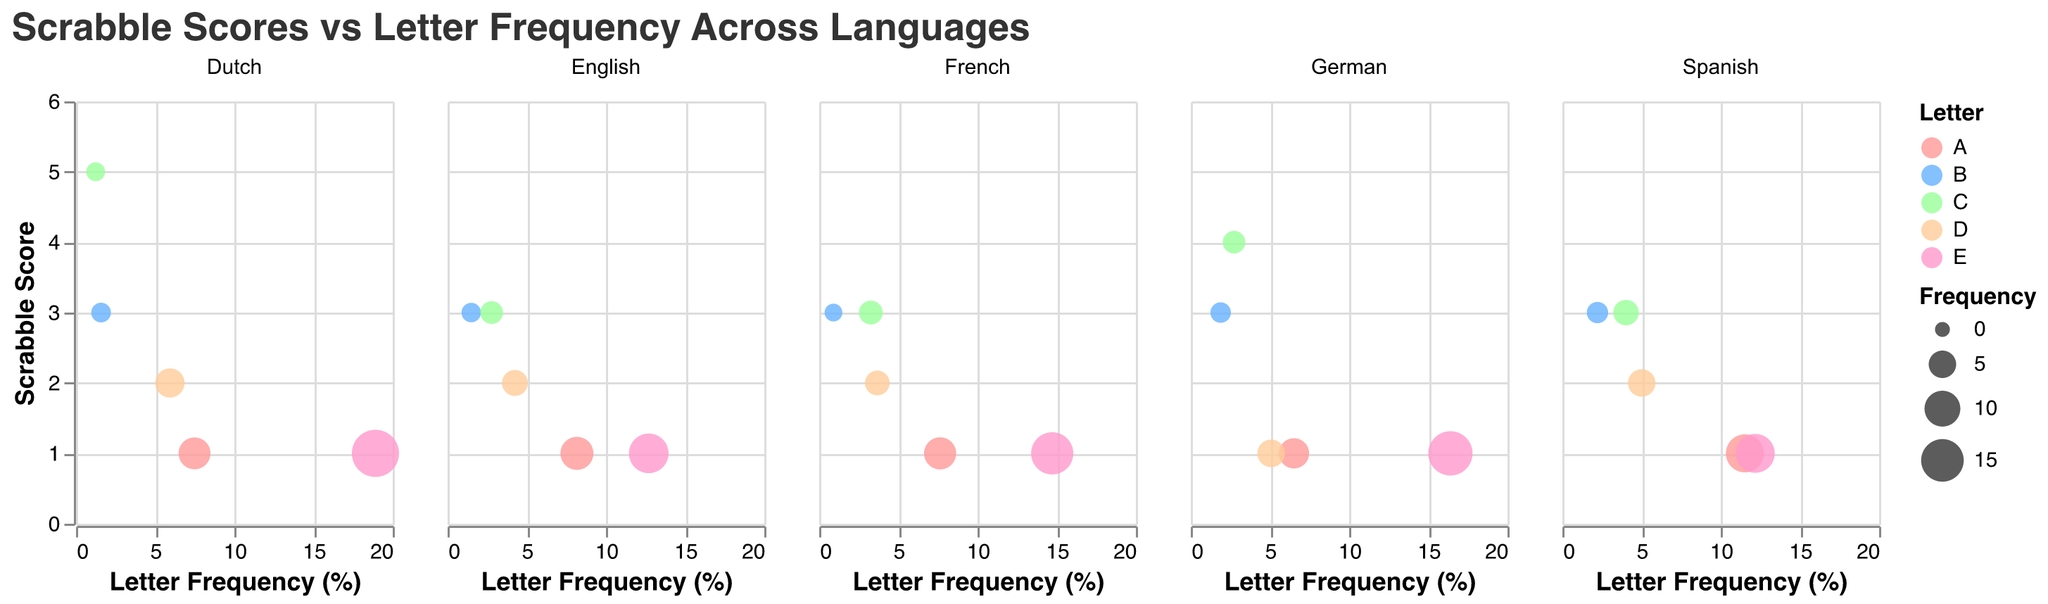What is the title of the figure? The title is displayed at the top of the figure in a larger, bold font for clarity. It reads "Scrabble Scores vs Letter Frequency Across Languages".
Answer: Scrabble Scores vs Letter Frequency Across Languages What is the range of the Letter Frequency axis? The X-axis represents Letter Frequency (%) and is set from 0 to 20, which is indicated by the axis scale in the plot.
Answer: 0 to 20 Which letter has the highest frequency in the Dutch language? In the sub-plot for Dutch, the bubble for the letter E is the largest, indicating that it has the highest frequency. The tooltip confirms this with a frequency of 18.91%.
Answer: E How many data points are plotted for the English language? The English language subplot has bubbles representing the letters A, B, C, D, and E. Counting these gives us 5 data points.
Answer: 5 Which letter in Spanish has a frequency above 10%? For Spanish, the bubbles representing letter frequencies show that both A and E have frequencies above 10%. The exact frequencies are displayed in the tooltip when hovered over these bubbles.
Answer: A and E What is the average Scrabble score for the letter C across all languages presented? Adding the Scrabble scores for C from English (3), Spanish (3), German (4), French (3), and Dutch (5), we get a total of 18. There are 5 languages, so the average score is 18/5 = 3.6.
Answer: 3.6 Which language has the highest frequency for the letter E? Observing the size of the bubbles and verifying with the tooltip, the subplot for Dutch shows that E has the highest frequency of 18.91%.
Answer: Dutch Compare the Scrabble score for the letter D in English and French. Which language has a higher score? Referring to the bubble positions on the Y-axis under English and French, English has a score of 2, and French has a score of 2 as well, so they are equal.
Answer: Equal What is the size range for the bubbles in the chart? The bubble size varies from a minimum size, corresponding to a frequency value being mapped to "50", to a maximum size value mapped to "500". This variation in bubble size reflects frequencies proportionally.
Answer: 50 to 500 